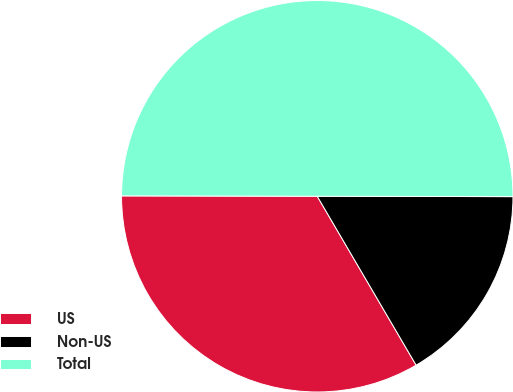Convert chart. <chart><loc_0><loc_0><loc_500><loc_500><pie_chart><fcel>US<fcel>Non-US<fcel>Total<nl><fcel>33.46%<fcel>16.54%<fcel>50.0%<nl></chart> 